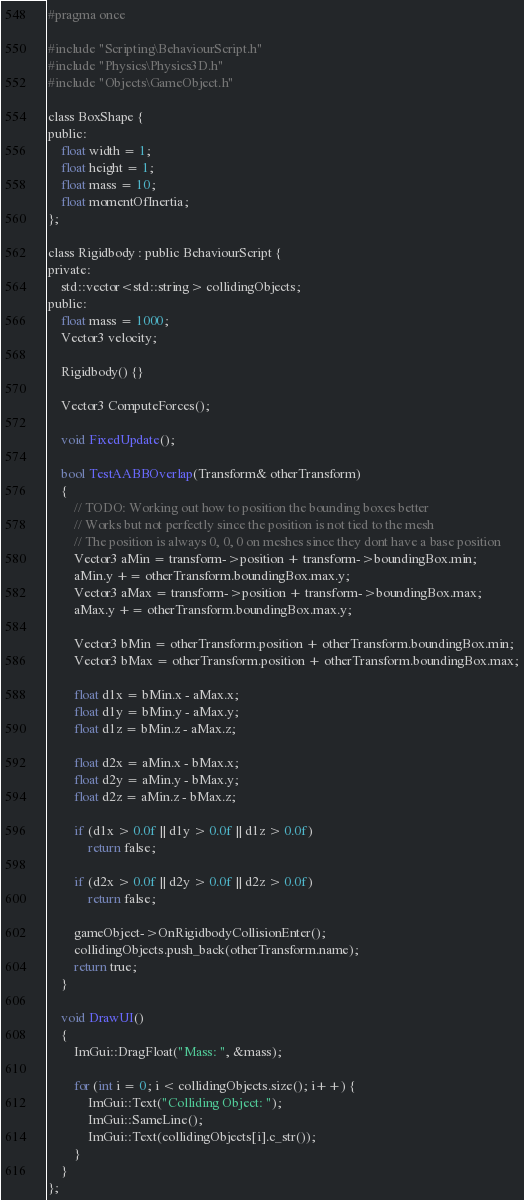<code> <loc_0><loc_0><loc_500><loc_500><_C_>#pragma once

#include "Scripting\BehaviourScript.h"
#include "Physics\Physics3D.h"
#include "Objects\GameObject.h"

class BoxShape {
public:
	float width = 1;
	float height = 1;
	float mass = 10;
	float momentOfInertia;
};

class Rigidbody : public BehaviourScript {
private:
	std::vector<std::string> collidingObjects;
public:
	float mass = 1000;
	Vector3 velocity;

	Rigidbody() {}

	Vector3 ComputeForces();

	void FixedUpdate();

	bool TestAABBOverlap(Transform& otherTransform)
	{
		// TODO: Working out how to position the bounding boxes better
		// Works but not perfectly since the position is not tied to the mesh
		// The position is always 0, 0, 0 on meshes since they dont have a base position
		Vector3 aMin = transform->position + transform->boundingBox.min;
		aMin.y += otherTransform.boundingBox.max.y;
		Vector3 aMax = transform->position + transform->boundingBox.max;
		aMax.y += otherTransform.boundingBox.max.y;

		Vector3 bMin = otherTransform.position + otherTransform.boundingBox.min;
		Vector3 bMax = otherTransform.position + otherTransform.boundingBox.max;

		float d1x = bMin.x - aMax.x;
		float d1y = bMin.y - aMax.y;
		float d1z = bMin.z - aMax.z;

		float d2x = aMin.x - bMax.x;
		float d2y = aMin.y - bMax.y;
		float d2z = aMin.z - bMax.z;

		if (d1x > 0.0f || d1y > 0.0f || d1z > 0.0f)
			return false;

		if (d2x > 0.0f || d2y > 0.0f || d2z > 0.0f)
			return false;

		gameObject->OnRigidbodyCollisionEnter();
		collidingObjects.push_back(otherTransform.name);
		return true;
	}

	void DrawUI()
	{
		ImGui::DragFloat("Mass: ", &mass);

		for (int i = 0; i < collidingObjects.size(); i++) {
			ImGui::Text("Colliding Object: ");
			ImGui::SameLine();
			ImGui::Text(collidingObjects[i].c_str());
		}
	}
};</code> 